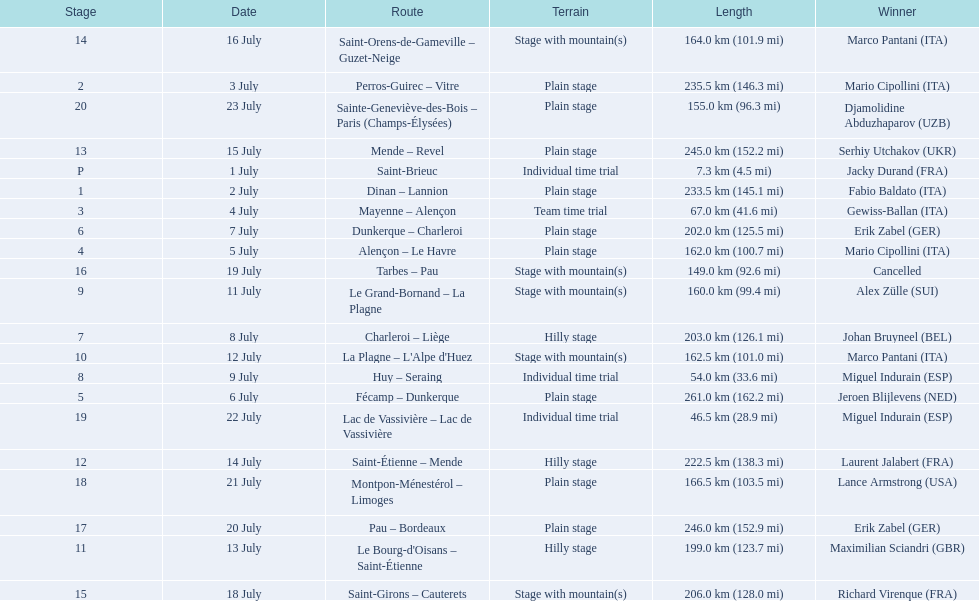What are the dates? 1 July, 2 July, 3 July, 4 July, 5 July, 6 July, 7 July, 8 July, 9 July, 11 July, 12 July, 13 July, 14 July, 15 July, 16 July, 18 July, 19 July, 20 July, 21 July, 22 July, 23 July. What is the length on 8 july? 203.0 km (126.1 mi). 